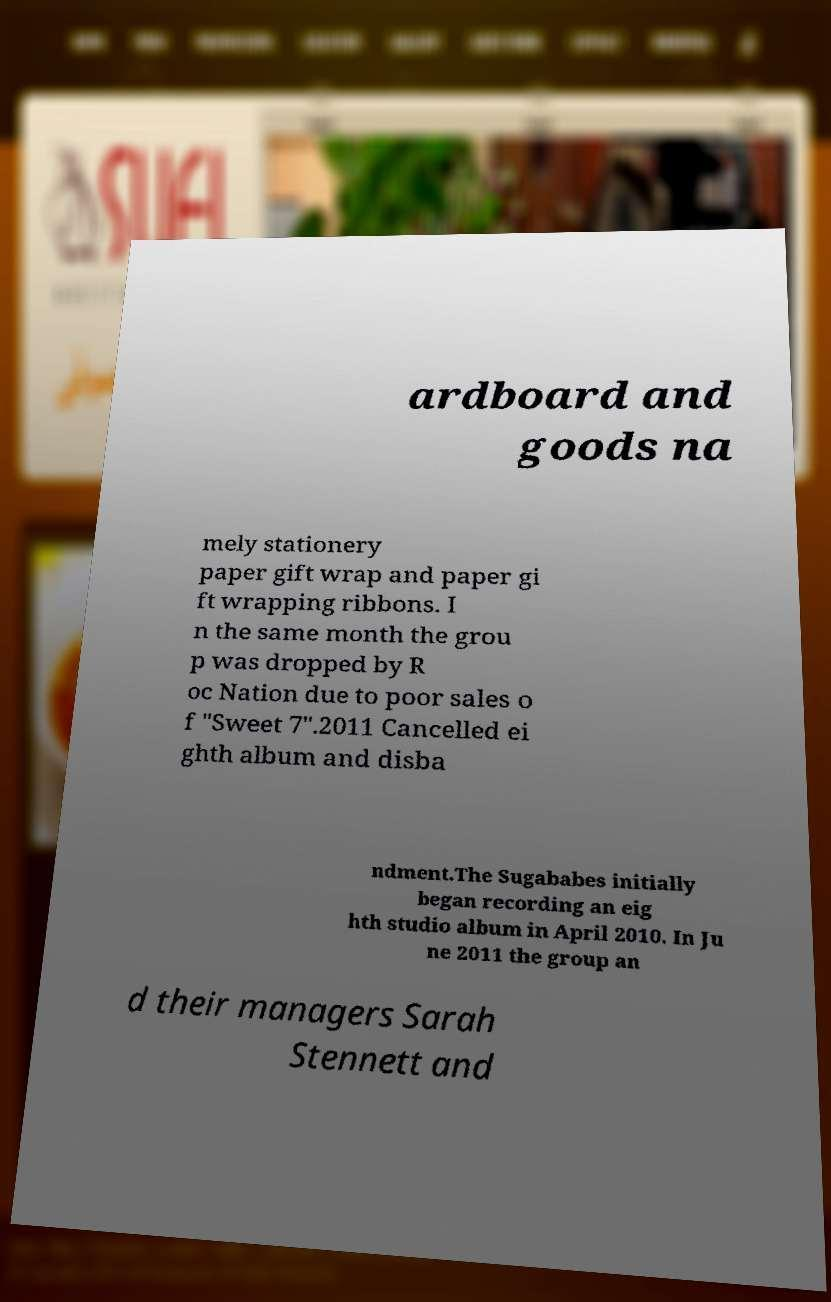What messages or text are displayed in this image? I need them in a readable, typed format. ardboard and goods na mely stationery paper gift wrap and paper gi ft wrapping ribbons. I n the same month the grou p was dropped by R oc Nation due to poor sales o f "Sweet 7".2011 Cancelled ei ghth album and disba ndment.The Sugababes initially began recording an eig hth studio album in April 2010. In Ju ne 2011 the group an d their managers Sarah Stennett and 